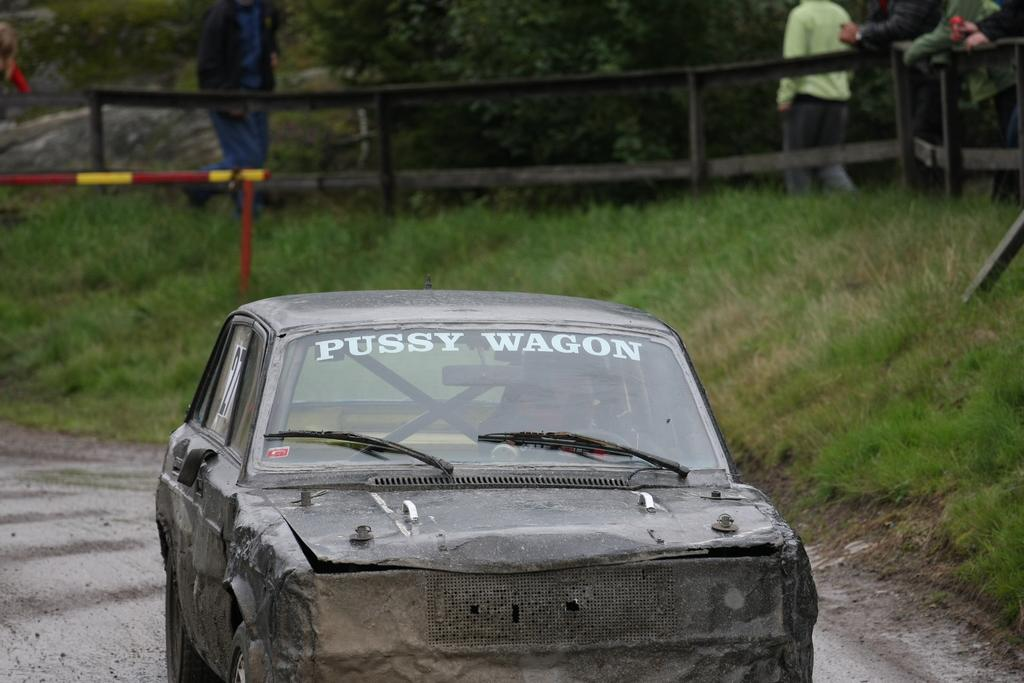What is the main subject of the image? The main subject of the image is a car. Can you describe the car's position in the image? The car is on a surface in the image. What type of natural environment is visible in the image? There is grass visible in the image, and there are trees in the background. Are there any people present in the image? Yes, there are people in the background of the image. What type of cork can be seen on the car's tires in the image? There is no cork present on the car's tires in the image. Is the image taken during the winter season? The provided facts do not mention any specific season or weather conditions, so it cannot be determined if the image was taken during the winter season. 